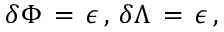Convert formula to latex. <formula><loc_0><loc_0><loc_500><loc_500>\delta \Phi \, = \, \epsilon \, , \, \delta \Lambda \, = \, \epsilon \, ,</formula> 